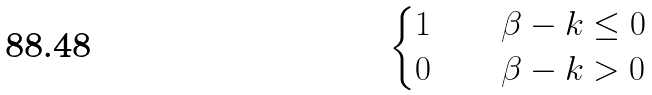Convert formula to latex. <formula><loc_0><loc_0><loc_500><loc_500>\begin{cases} 1 & \quad \beta - k \leq 0 \\ 0 & \quad \beta - k > 0 \end{cases}</formula> 